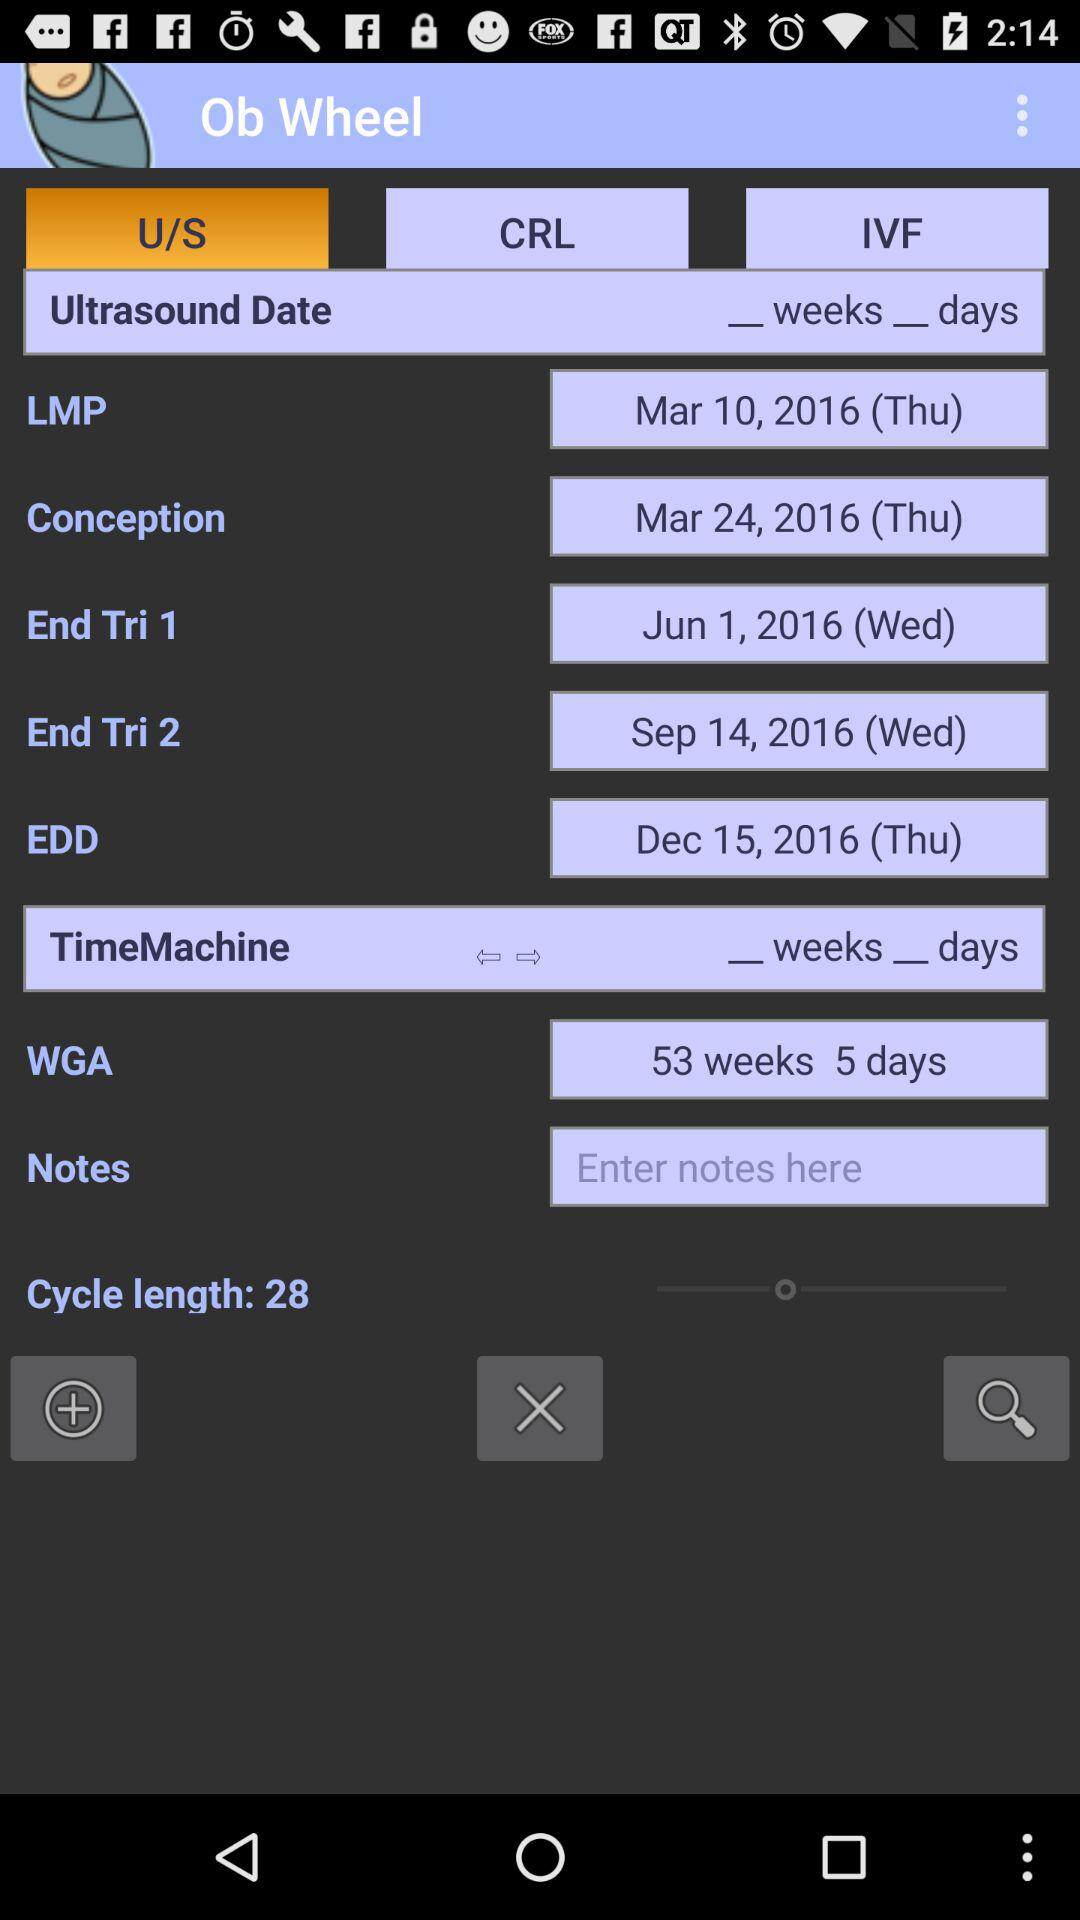What is the number of weeks and days in the WGA? The number of weeks and days is 53 and 5, respectively. 